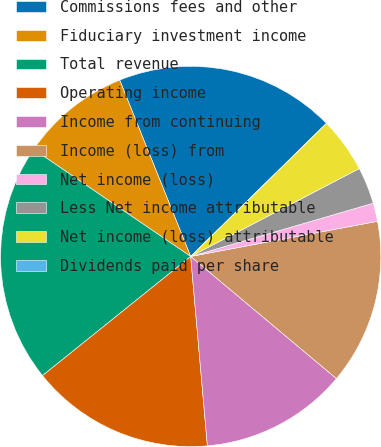Convert chart to OTSL. <chart><loc_0><loc_0><loc_500><loc_500><pie_chart><fcel>Commissions fees and other<fcel>Fiduciary investment income<fcel>Total revenue<fcel>Operating income<fcel>Income from continuing<fcel>Income (loss) from<fcel>Net income (loss)<fcel>Less Net income attributable<fcel>Net income (loss) attributable<fcel>Dividends paid per share<nl><fcel>18.75%<fcel>9.38%<fcel>20.31%<fcel>15.62%<fcel>12.5%<fcel>14.06%<fcel>1.56%<fcel>3.13%<fcel>4.69%<fcel>0.0%<nl></chart> 